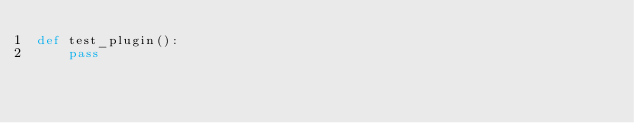<code> <loc_0><loc_0><loc_500><loc_500><_Python_>def test_plugin():
    pass</code> 